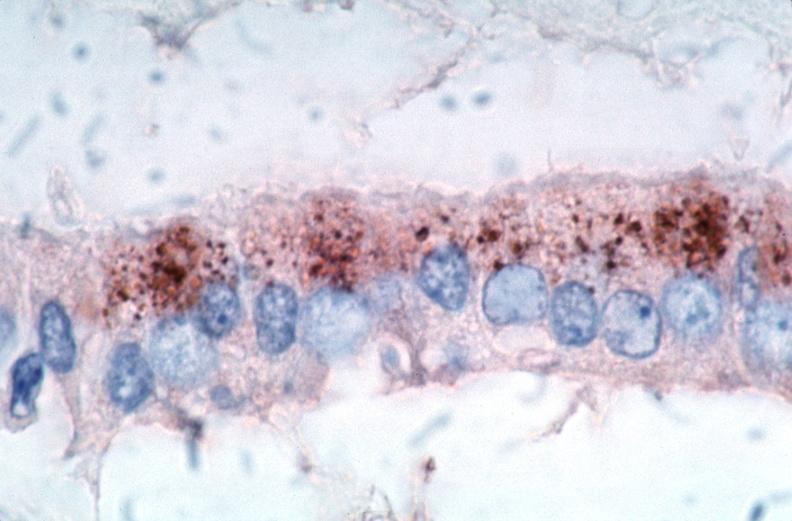what is present?
Answer the question using a single word or phrase. Cardiovascular 